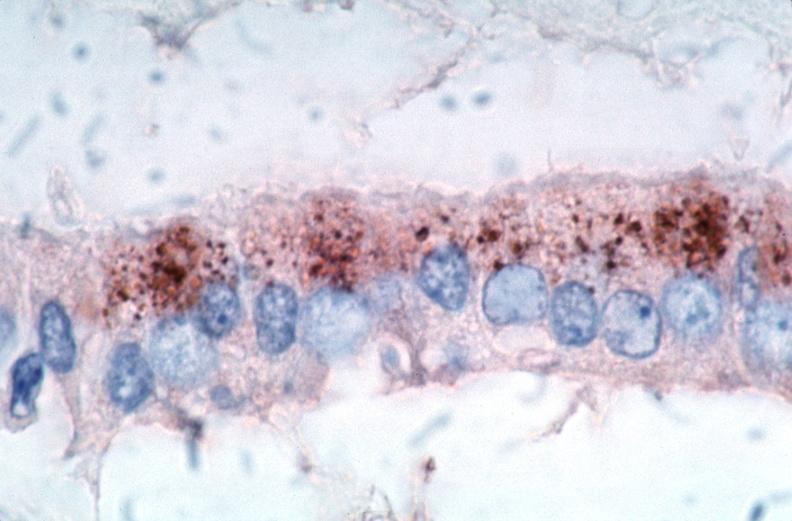what is present?
Answer the question using a single word or phrase. Cardiovascular 